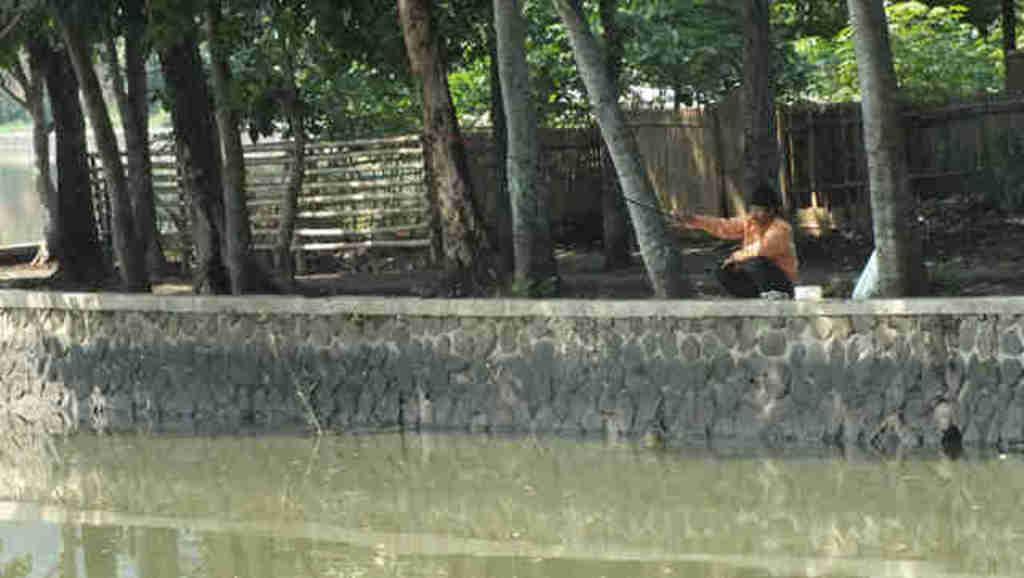Please provide a concise description of this image. In the foreground of the picture there is a water body and a wall. In the center of the picture there are trees, fencing and a person fishing. In the background there are trees. 